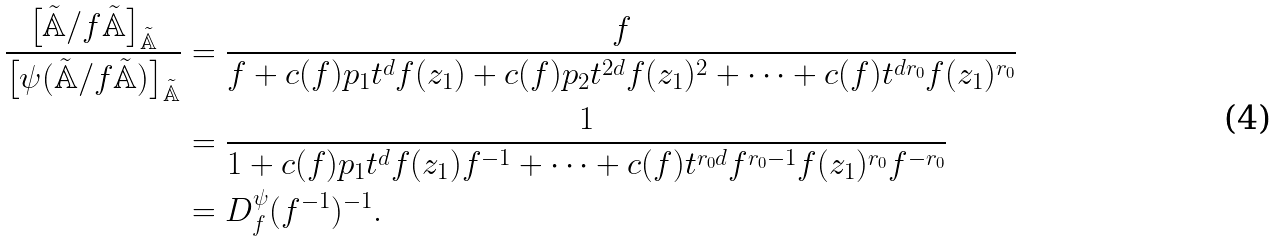<formula> <loc_0><loc_0><loc_500><loc_500>\frac { \left [ \tilde { \mathbb { A } } / f \tilde { \mathbb { A } } \right ] _ { \tilde { \mathbb { A } } } } { \left [ \psi ( \tilde { \mathbb { A } } / f \tilde { \mathbb { A } } ) \right ] _ { \tilde { \mathbb { A } } } } & = \frac { f } { f + c ( f ) p _ { 1 } t ^ { d } f ( z _ { 1 } ) + c ( f ) p _ { 2 } t ^ { 2 d } f ( z _ { 1 } ) ^ { 2 } + \dots + c ( f ) t ^ { d r _ { 0 } } f ( z _ { 1 } ) ^ { r _ { 0 } } } \\ & = \frac { 1 } { 1 + c ( f ) p _ { 1 } t ^ { d } f ( z _ { 1 } ) f ^ { - 1 } + \dots + c ( f ) t ^ { r _ { 0 } d } f ^ { r _ { 0 } - 1 } f ( z _ { 1 } ) ^ { r _ { 0 } } f ^ { - r _ { 0 } } } \\ & = D ^ { \psi } _ { f } ( f ^ { - 1 } ) ^ { - 1 } .</formula> 